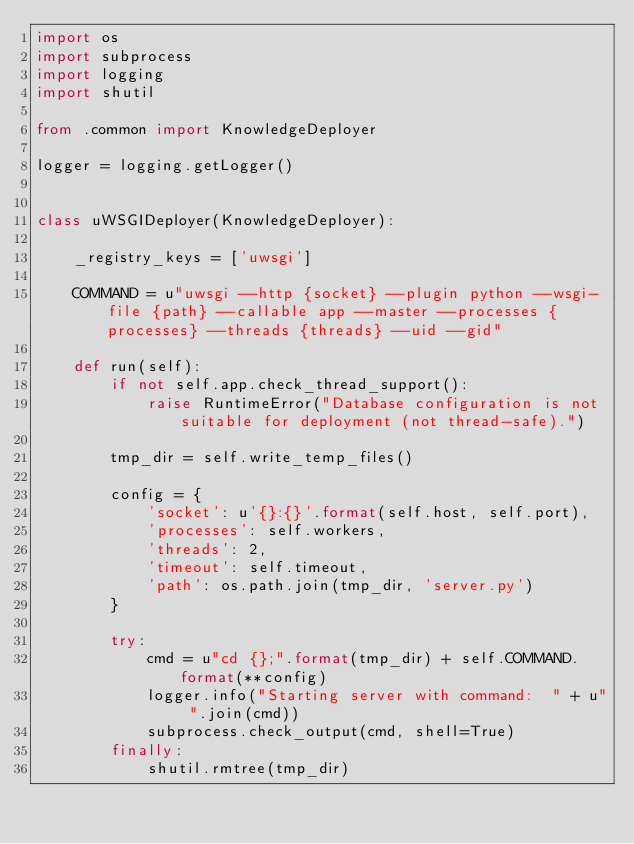Convert code to text. <code><loc_0><loc_0><loc_500><loc_500><_Python_>import os
import subprocess
import logging
import shutil

from .common import KnowledgeDeployer

logger = logging.getLogger()


class uWSGIDeployer(KnowledgeDeployer):

    _registry_keys = ['uwsgi']

    COMMAND = u"uwsgi --http {socket} --plugin python --wsgi-file {path} --callable app --master --processes {processes} --threads {threads} --uid --gid"

    def run(self):
        if not self.app.check_thread_support():
            raise RuntimeError("Database configuration is not suitable for deployment (not thread-safe).")

        tmp_dir = self.write_temp_files()

        config = {
            'socket': u'{}:{}'.format(self.host, self.port),
            'processes': self.workers,
            'threads': 2,
            'timeout': self.timeout,
            'path': os.path.join(tmp_dir, 'server.py')
        }

        try:
            cmd = u"cd {};".format(tmp_dir) + self.COMMAND.format(**config)
            logger.info("Starting server with command:  " + u" ".join(cmd))
            subprocess.check_output(cmd, shell=True)
        finally:
            shutil.rmtree(tmp_dir)
</code> 